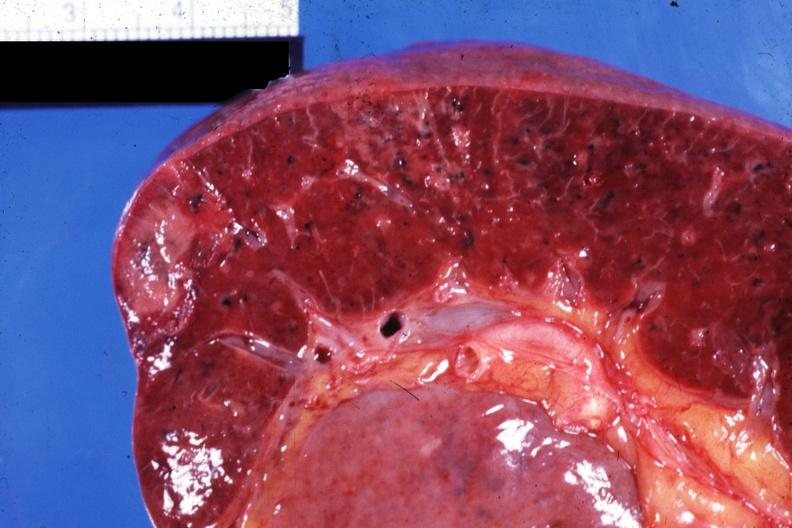why does this image show close-up view of infarcts?
Answer the question using a single word or phrase. Due to nonbacterial endocarditis 88yom with body burns 